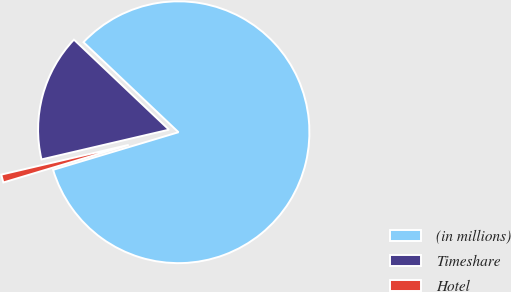<chart> <loc_0><loc_0><loc_500><loc_500><pie_chart><fcel>(in millions)<fcel>Timeshare<fcel>Hotel<nl><fcel>83.29%<fcel>15.72%<fcel>0.99%<nl></chart> 